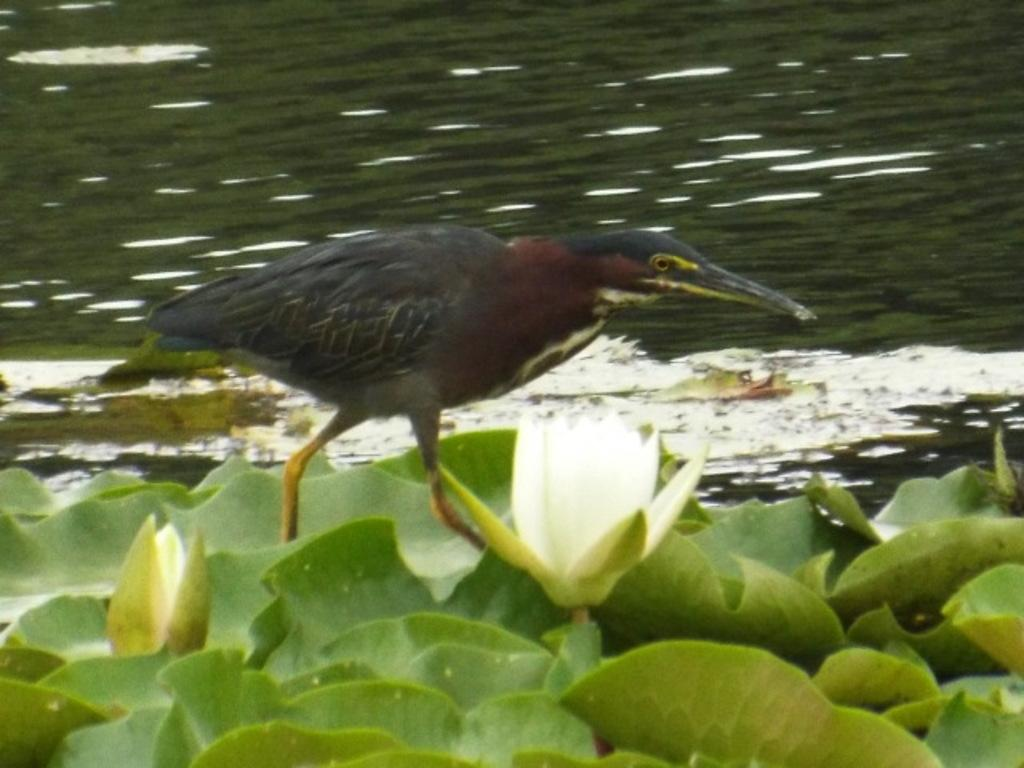What is the setting of the image? The image is an outside view. What can be seen in the middle of the image? There is a bird in the middle of the image. What type of vegetation is at the bottom of the image? There are plants at the bottom of the image. What is visible at the top of the image? There is water visible at the top of the image. What type of mist can be seen surrounding the bird in the image? There is no mist present in the image; it is a clear outside view with a bird, plants, and water visible. 